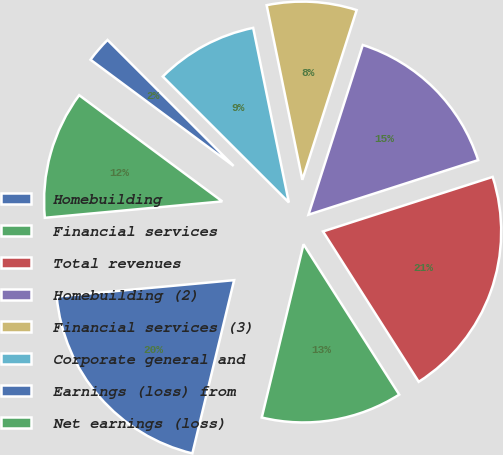<chart> <loc_0><loc_0><loc_500><loc_500><pie_chart><fcel>Homebuilding<fcel>Financial services<fcel>Total revenues<fcel>Homebuilding (2)<fcel>Financial services (3)<fcel>Corporate general and<fcel>Earnings (loss) from<fcel>Net earnings (loss)<nl><fcel>19.77%<fcel>12.79%<fcel>20.93%<fcel>15.12%<fcel>8.14%<fcel>9.3%<fcel>2.33%<fcel>11.63%<nl></chart> 